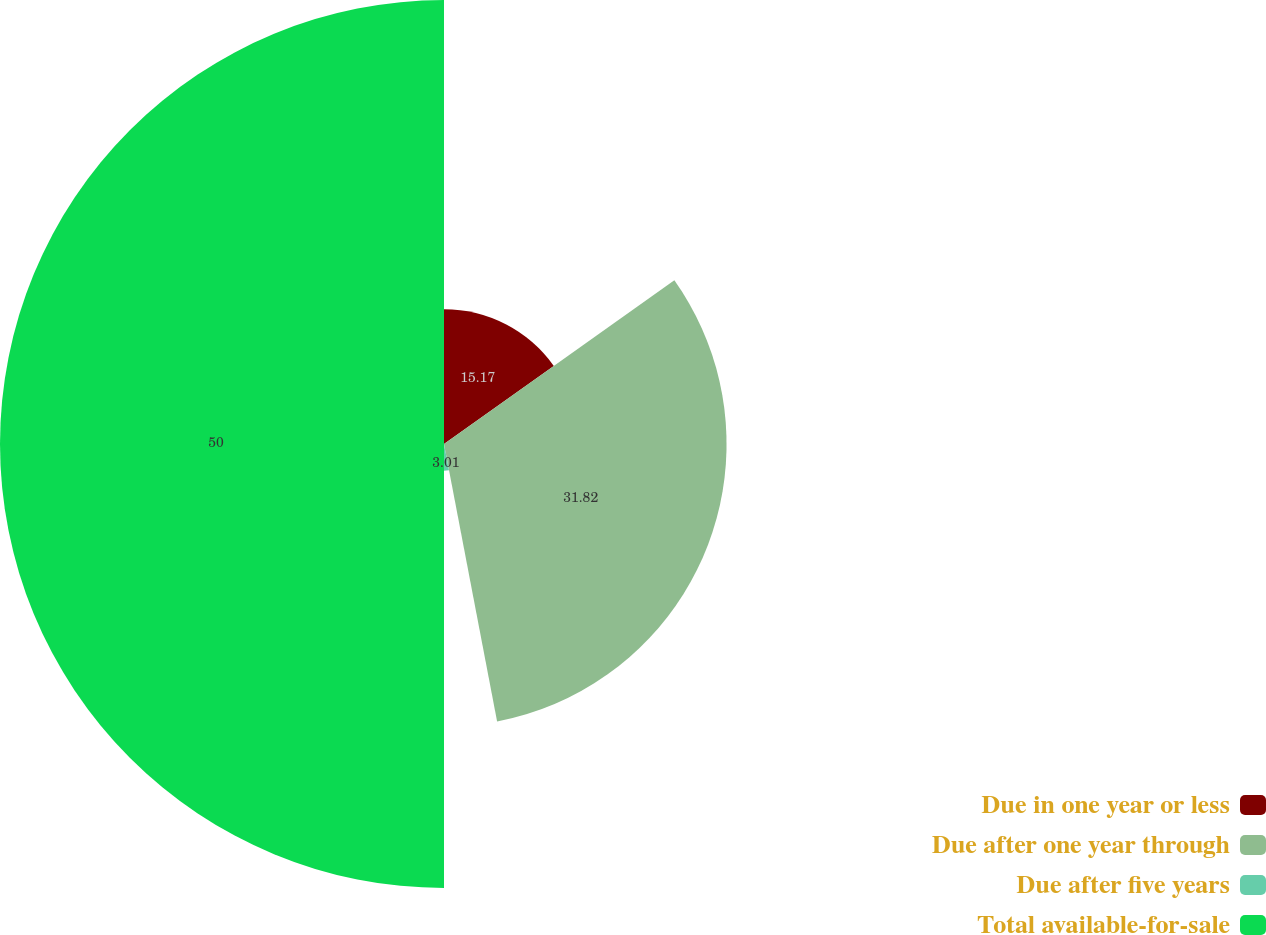Convert chart. <chart><loc_0><loc_0><loc_500><loc_500><pie_chart><fcel>Due in one year or less<fcel>Due after one year through<fcel>Due after five years<fcel>Total available-for-sale<nl><fcel>15.17%<fcel>31.82%<fcel>3.01%<fcel>50.0%<nl></chart> 